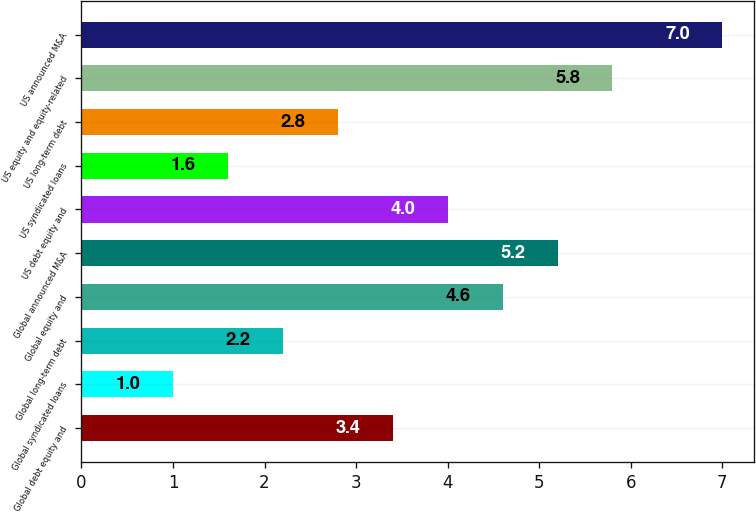Convert chart to OTSL. <chart><loc_0><loc_0><loc_500><loc_500><bar_chart><fcel>Global debt equity and<fcel>Global syndicated loans<fcel>Global long-term debt<fcel>Global equity and<fcel>Global announced M&A<fcel>US debt equity and<fcel>US syndicated loans<fcel>US long-term debt<fcel>US equity and equity-related<fcel>US announced M&A<nl><fcel>3.4<fcel>1<fcel>2.2<fcel>4.6<fcel>5.2<fcel>4<fcel>1.6<fcel>2.8<fcel>5.8<fcel>7<nl></chart> 